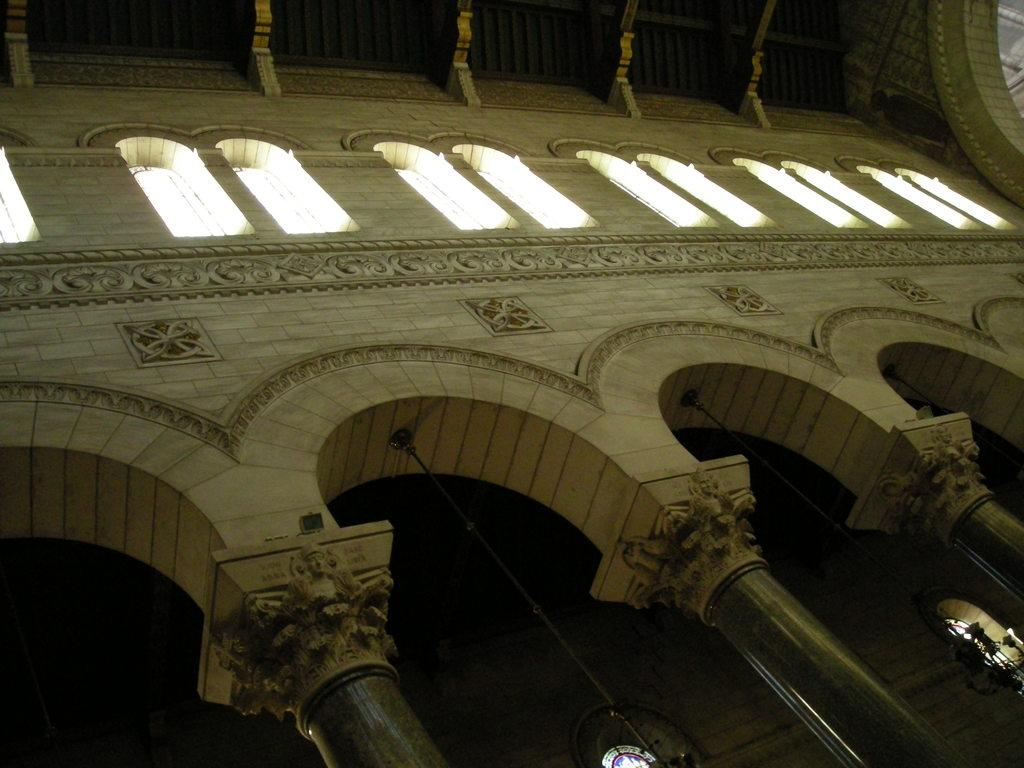Where was the image taken? The image was taken inside a palace. What architectural features can be seen in the palace? There are windows and pillars in the palace. What is special about the pillars in the palace? The pillars have beautiful carvings. What type of space-themed decorations can be seen in the palace? There is no mention of space-themed decorations in the image or the provided facts. 